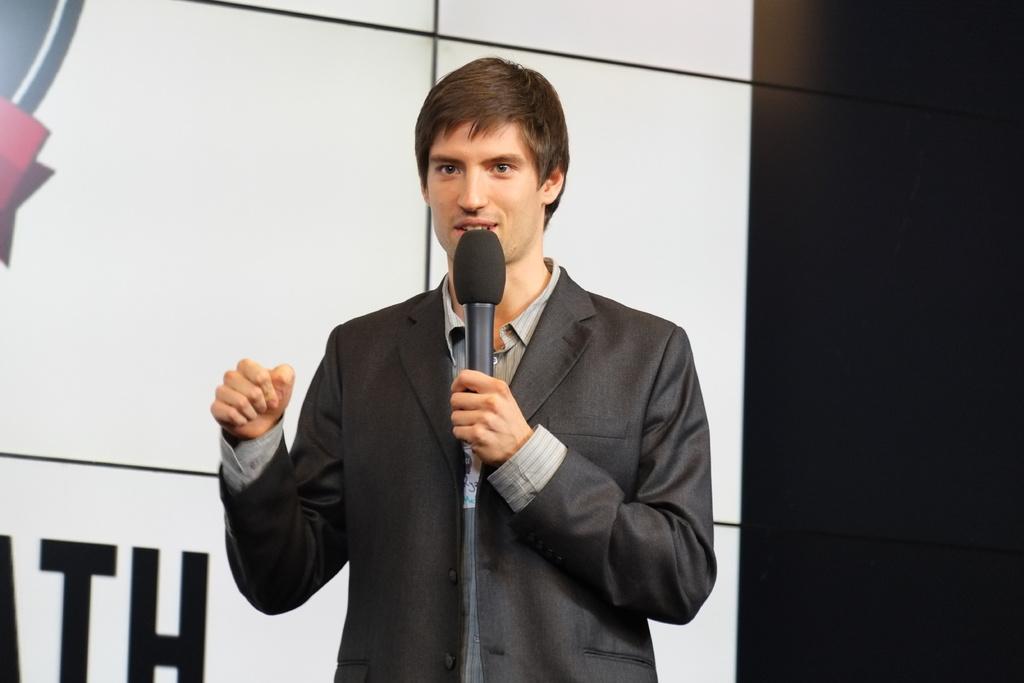Can you describe this image briefly? in this image i can see a person talking. he is holding a microphone. he is wearing a suit. 